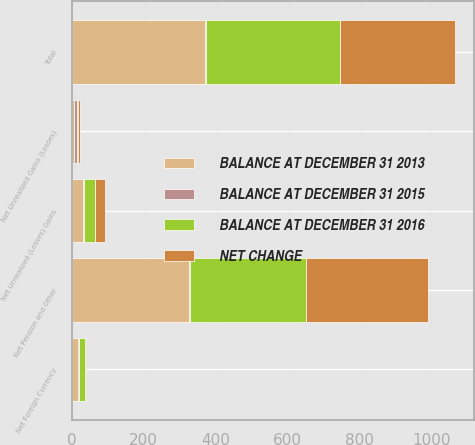Convert chart. <chart><loc_0><loc_0><loc_500><loc_500><stacked_bar_chart><ecel><fcel>Net Unrealized (Losses) Gains<fcel>Net Unrealized Gains (Losses)<fcel>Net Foreign Currency<fcel>Net Pension and Other<fcel>Total<nl><fcel>BALANCE AT DECEMBER 31 2013<fcel>32.4<fcel>6.1<fcel>18.5<fcel>325.2<fcel>370<nl><fcel>BALANCE AT DECEMBER 31 2015<fcel>1.4<fcel>9.1<fcel>0.9<fcel>4.1<fcel>2.7<nl><fcel>BALANCE AT DECEMBER 31 2016<fcel>31<fcel>3<fcel>17.6<fcel>321.1<fcel>372.7<nl><fcel>NET CHANGE<fcel>27.6<fcel>4.7<fcel>1.7<fcel>340.9<fcel>319.7<nl></chart> 